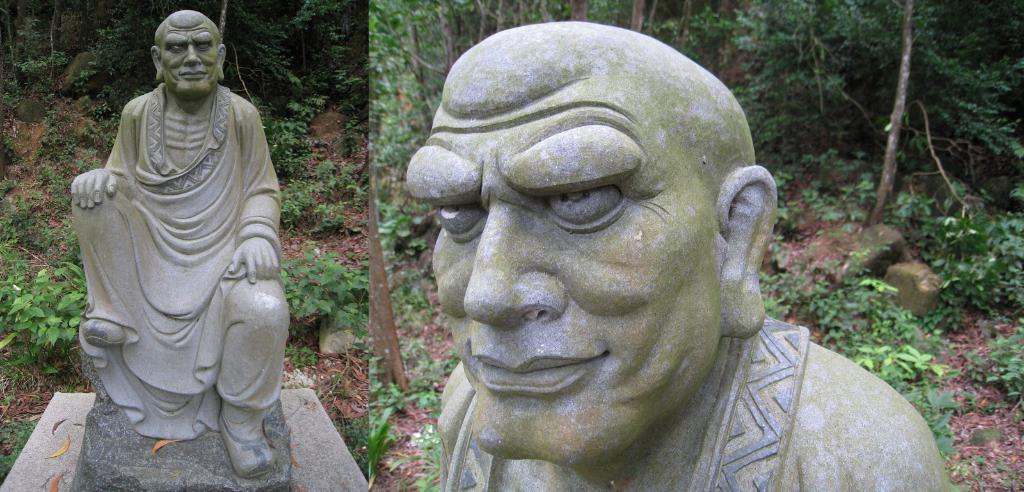How many images are combined in the collage? The image is a collage of two images. What is depicted in both images? There is a statue of a human in both images. What type of vegetation can be seen in the background of at least one of the images? There are plants and trees in the background of at least one of the images. What type of sack is being carried by the statue in the image? There is no sack being carried by the statue in the image; it is a statue of a human without any additional objects. 